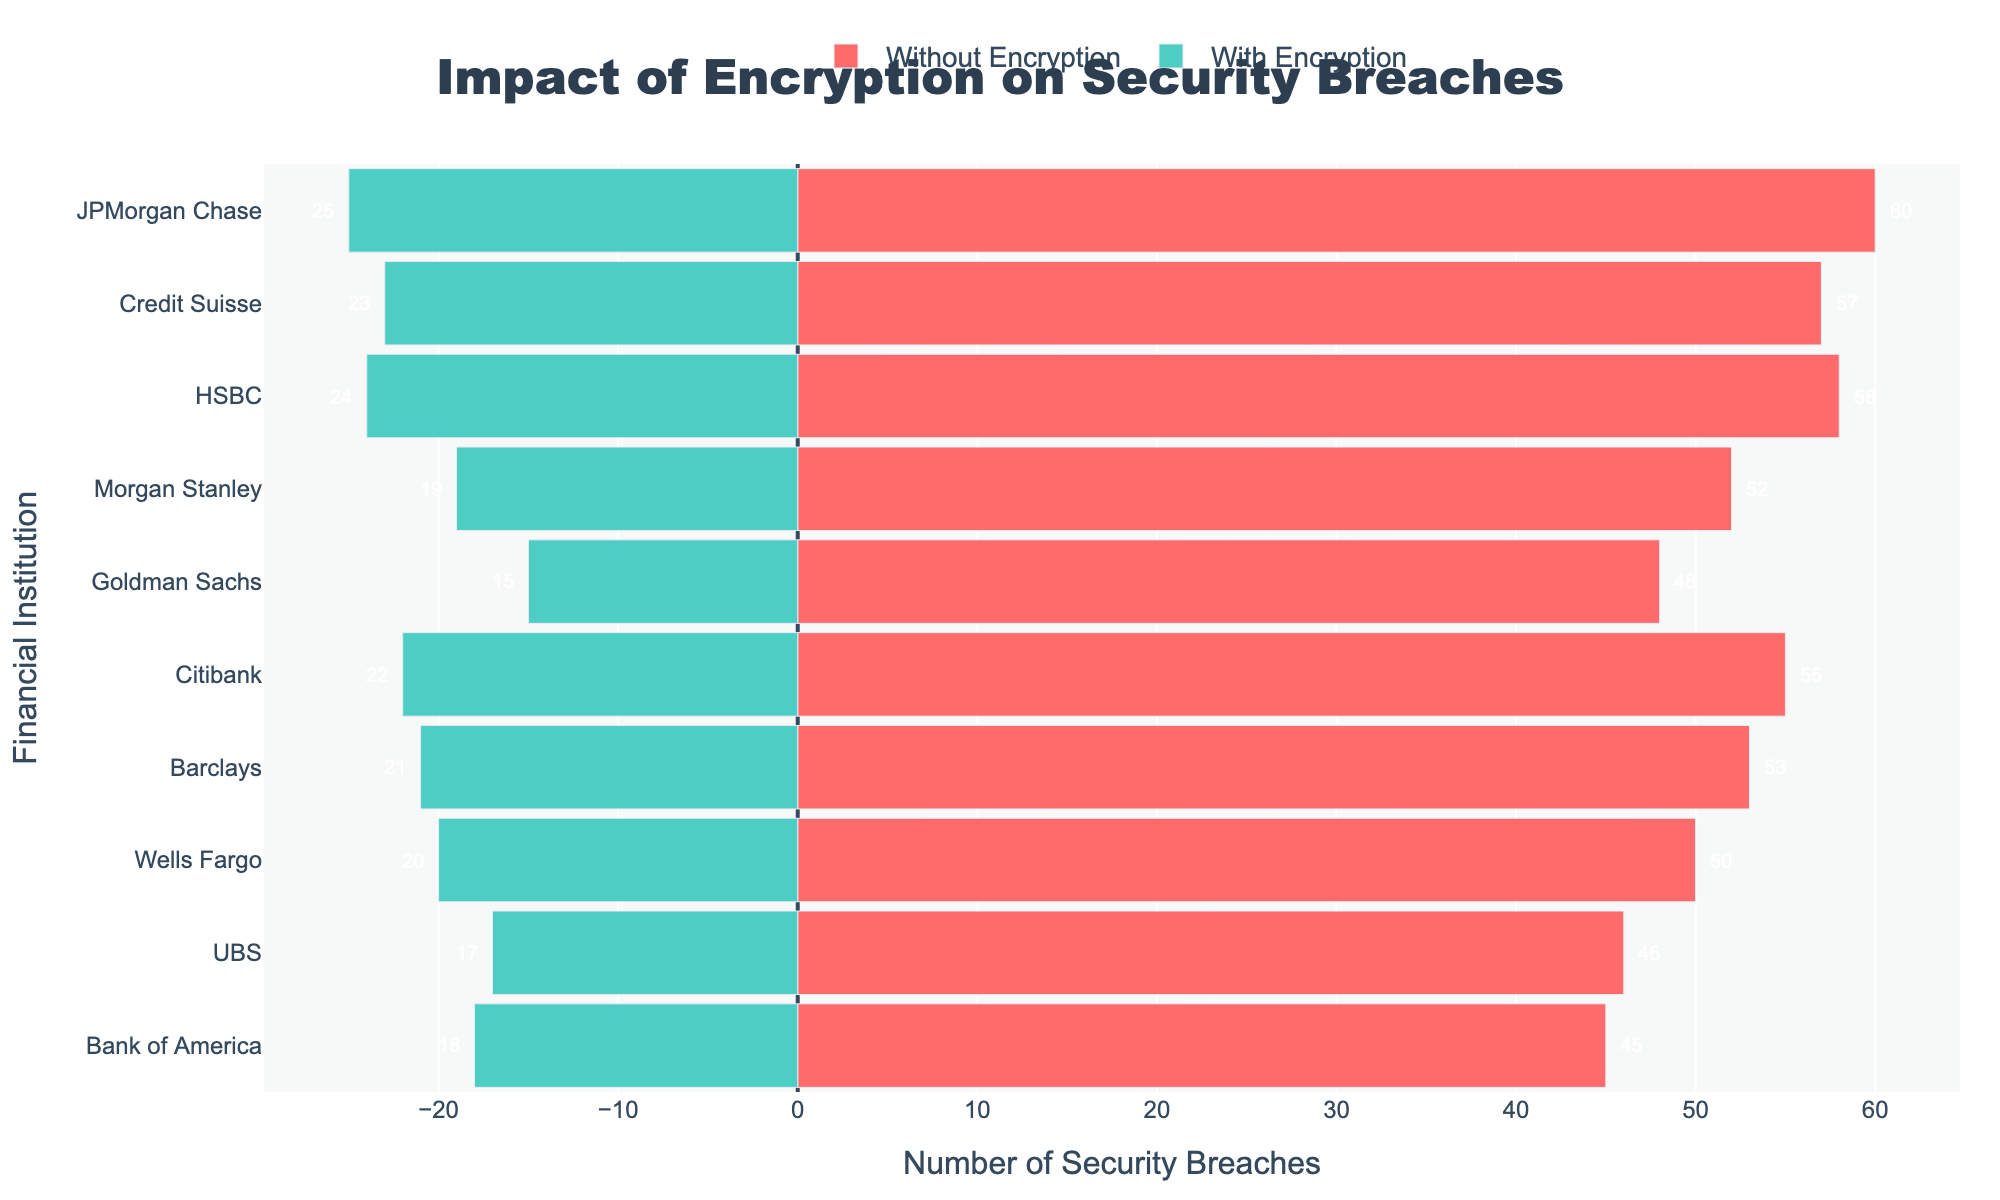How many more security breaches did JPMorgan Chase experience without encryption compared to with encryption? JPMorgan Chase had 60 security breaches without encryption and 25 with encryption. The difference is 60 - 25 = 35 breaches.
Answer: 35 Which financial institution had the smallest reduction in security breaches after implementing encryption? Citibank had 55 breaches without encryption and 22 with encryption, a reduction of 33, which is the smallest reduction among all institutions.
Answer: Citibank What is the total number of security breaches across all companies with encryption? Sum the security breaches with encryption for all companies: 18 + 20 + 22 + 25 + 15 + 19 + 24 + 21 + 17 + 23 = 204 breaches.
Answer: 204 Which company has the largest difference between breaches with and without encryption? JPMorgan Chase showed the largest difference, with 60 breaches without encryption and 25 with, resulting in 35 fewer breaches.
Answer: JPMorgan Chase Are there more security breaches without encryption at Credit Suisse or Barclays? Credit Suisse had 57 breaches without encryption, while Barclays had 53, meaning Credit Suisse had more breaches.
Answer: Credit Suisse By how many breaches does Wells Fargo reduce its breaches when encryption is implemented compared to Morgan Stanley? Wells Fargo reduces from 50 to 20 breaches, a reduction of 30. Morgan Stanley reduces from 52 to 19 breaches, a reduction of 33. The comparison is 33 (Morgan Stanley) - 30 (Wells Fargo) = 3 more breaches reduced.
Answer: 3 Which institutions have less than 20 security breaches with encryption? By examining the green bars, Bank of America (18), Goldman Sachs (15), Morgan Stanley (19), and UBS (17) all have fewer than 20 breaches with encryption.
Answer: Bank of America, Goldman Sachs, Morgan Stanley, UBS How many more breaches did HSBC have without encryption compared to Bank of America? HSBC had 58 breaches without encryption, while Bank of America had 45. So, 58 - 45 = 13 more breaches.
Answer: 13 What is the average reduction in security breaches after implementing encryption for all companies? Sum the differences for all companies: (45-18) + (50-20) + (55-22) + (60-25) + (48-15) + (52-19) + (58-24) + (53-21) + (46-17) + (57-23) = 33 + 30 + 33 + 35 + 33 + 33 + 34 + 32 + 29 + 34 = 326. The average is 326 / 10 = 32.6
Answer: 32.6 Which company had more breaches without encryption, Citibank or Barclays? Citibank had 55 breaches without encryption, while Barclays had 53. Therefore, Citibank had more breaches.
Answer: Citibank 